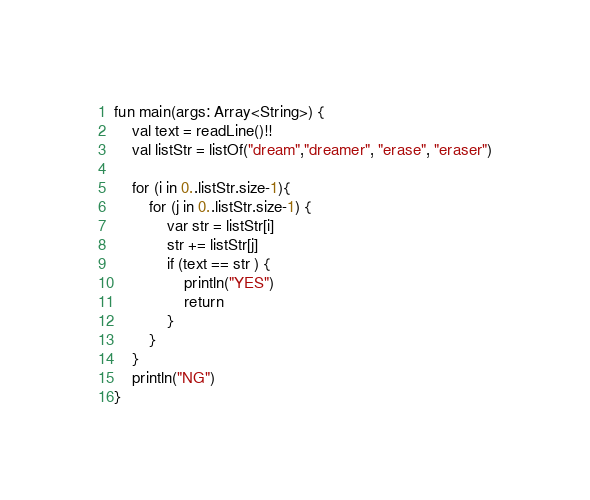Convert code to text. <code><loc_0><loc_0><loc_500><loc_500><_Kotlin_>fun main(args: Array<String>) {
    val text = readLine()!!
    val listStr = listOf("dream","dreamer", "erase", "eraser")
    
    for (i in 0..listStr.size-1){
        for (j in 0..listStr.size-1) {
            var str = listStr[i]
            str += listStr[j]
            if (text == str ) {
                println("YES")
                return
            } 
        }
    }
    println("NG")
}
</code> 